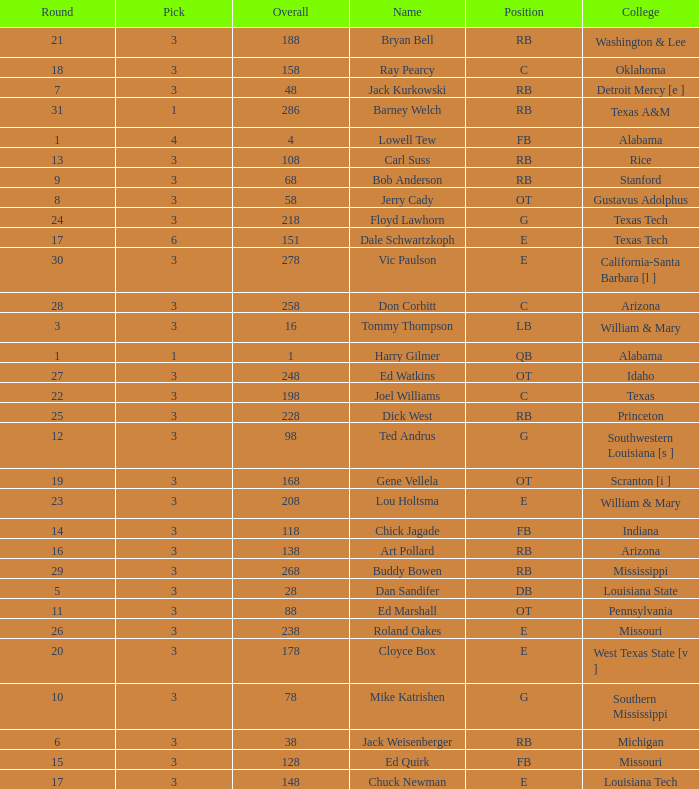Which Overall has a Name of bob anderson, and a Round smaller than 9? None. 